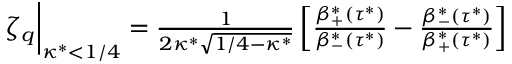Convert formula to latex. <formula><loc_0><loc_0><loc_500><loc_500>\begin{array} { r } { \zeta _ { q } \Big | _ { \kappa ^ { * } < 1 / 4 } = \frac { 1 } { 2 \kappa ^ { * } \sqrt { 1 / 4 - \kappa ^ { * } } } \left [ \frac { \beta _ { + } ^ { * } \left ( \tau ^ { * } \right ) } { \beta _ { - } ^ { * } \left ( \tau ^ { * } \right ) } - \frac { \beta _ { - } ^ { * } \left ( \tau ^ { * } \right ) } { \beta _ { + } ^ { * } \left ( \tau ^ { * } \right ) } \right ] } \end{array}</formula> 